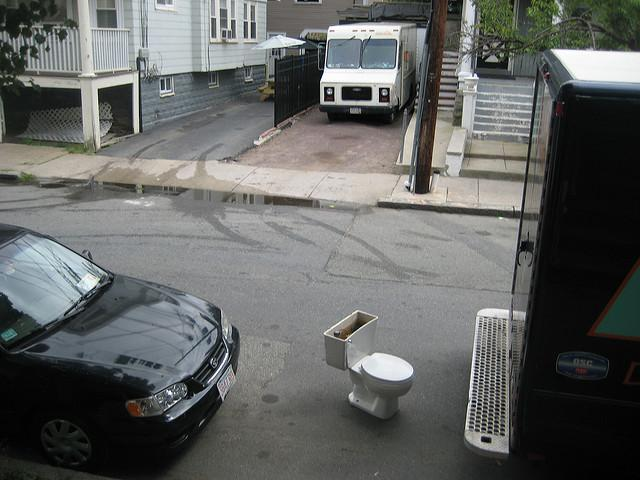What is between the car and the cube truck? toilet 